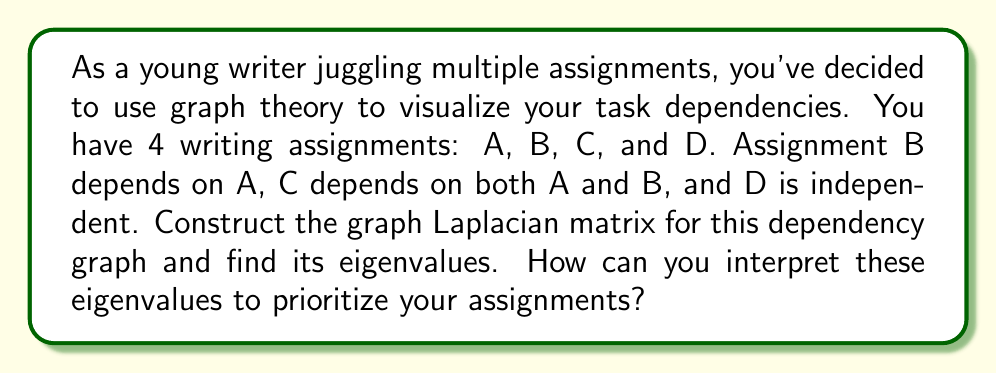Help me with this question. Let's approach this step-by-step:

1) First, we need to construct the adjacency matrix for the graph. The adjacency matrix A is:

   $$A = \begin{bmatrix}
   0 & 1 & 1 & 0 \\
   0 & 0 & 1 & 0 \\
   0 & 0 & 0 & 0 \\
   0 & 0 & 0 & 0
   \end{bmatrix}$$

2) Now, we need to calculate the degree matrix D. The degree of each vertex is:
   A: 2, B: 1, C: 0, D: 0

   So, the degree matrix D is:

   $$D = \begin{bmatrix}
   2 & 0 & 0 & 0 \\
   0 & 1 & 0 & 0 \\
   0 & 0 & 0 & 0 \\
   0 & 0 & 0 & 0
   \end{bmatrix}$$

3) The Laplacian matrix L is defined as L = D - A:

   $$L = D - A = \begin{bmatrix}
   2 & -1 & -1 & 0 \\
   0 & 1 & -1 & 0 \\
   0 & 0 & 0 & 0 \\
   0 & 0 & 0 & 0
   \end{bmatrix}$$

4) To find the eigenvalues, we need to solve the characteristic equation:
   $det(L - \lambda I) = 0$

   $\begin{vmatrix}
   2-\lambda & -1 & -1 & 0 \\
   0 & 1-\lambda & -1 & 0 \\
   0 & 0 & -\lambda & 0 \\
   0 & 0 & 0 & -\lambda
   \end{vmatrix} = 0$

5) Expanding this determinant:
   $(2-\lambda)(1-\lambda)(-\lambda)(-\lambda) = 0$

6) Solving this equation:
   $\lambda = 0$ (with multiplicity 2), $\lambda = 1$, $\lambda = 2$

7) Interpretation:
   - The number of zero eigenvalues (2) represents the number of connected components in the graph. This indicates that task D is isolated.
   - The largest eigenvalue (2) represents the maximum "effective resistance" in the graph, indicating the most critical path in your task dependencies.
   - The smallest non-zero eigenvalue (1) is related to the algebraic connectivity of the graph, suggesting how well-connected your tasks are overall.

8) For prioritization:
   - Start with task A, as it has the highest degree and is part of the critical path.
   - Follow with B, then C.
   - D can be done at any time as it's independent.

This spectral analysis helps visualize the structure of your task dependencies, allowing for more informed prioritization.
Answer: Eigenvalues: 0 (multiplicity 2), 1, 2. Prioritize: A, B, C, D (anytime). 